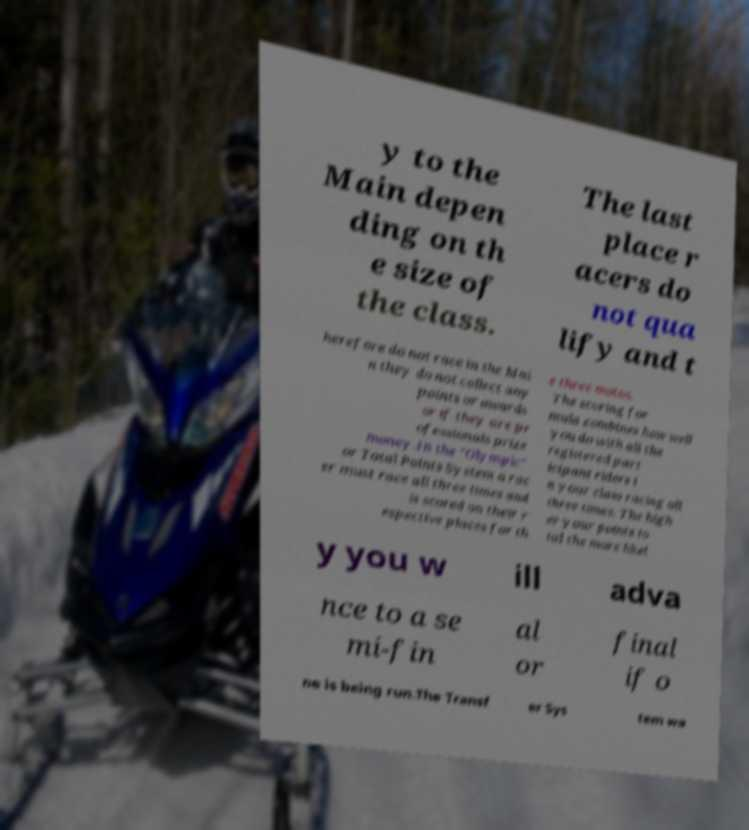I need the written content from this picture converted into text. Can you do that? y to the Main depen ding on th e size of the class. The last place r acers do not qua lify and t herefore do not race in the Mai n they do not collect any points or awards or if they are pr ofessionals prize money.In the "Olympic" or Total Points System a rac er must race all three times and is scored on their r espective places for th e three motos. The scoring for mula combines how well you do with all the registered part icipant riders i n your class racing all three times. The high er your points to tal the more likel y you w ill adva nce to a se mi-fin al or final if o ne is being run.The Transf er Sys tem wa 